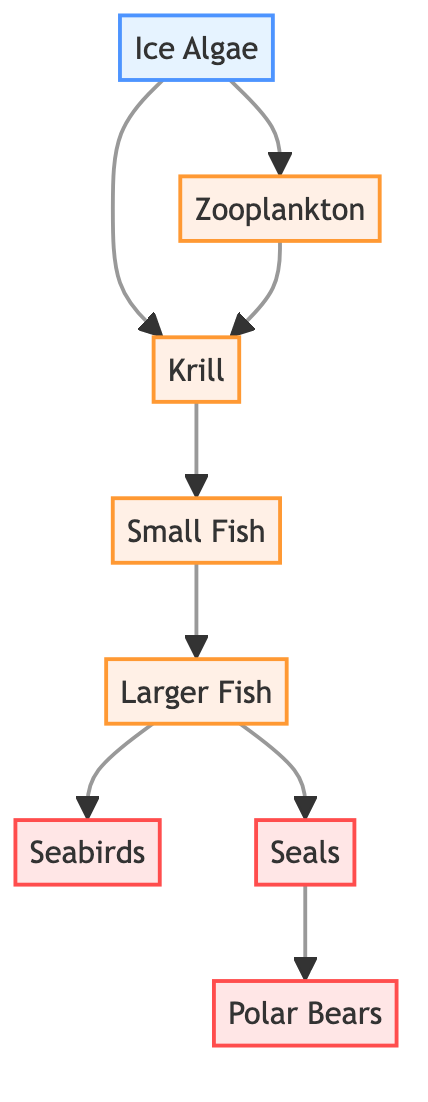What is the base of this food chain? The base of the food chain is depicted as the first node in the flowchart, which is Ice Algae.
Answer: Ice Algae How many consumers are present in the food chain? The consumers are the organisms that directly eat or receive energy from the primary producers. In the diagram, Zooplankton, Krill, Small Fish, Larger Fish, Seabirds, and Seals are all consumers, totaling six.
Answer: 6 Which organism directly feeds on Krill? In the diagram, the Small Fish, which is linked directly after Krill, are the ones that feed on Krill.
Answer: Small Fish Who is the apex predator in this food chain? The apex predator, occupying the highest position on the flowchart and not being eaten by any other organism in this network, is the Polar Bears.
Answer: Polar Bears What type of organisms are Seabirds considered in this food chain? In the structure of the food chain shown in the diagram, Seabirds are classified under the predator category, as they eat the Larger Fish.
Answer: Predator How many levels are there in this food chain from Ice Algae to Polar Bears? To determine the levels, we can count from Ice Algae at the base, moving through each tier until reaching Polar Bears. This results in a total of 7 levels.
Answer: 7 Which two organisms feed on Larger Fish? The diagram shows that Seabirds and Polar Bears both feed on Larger Fish, confirming their role as predators in the chain.
Answer: Seabirds and Polar Bears Is Krill a primary producer or a consumer in this ecosystem? Krill is not capable of photosynthesis and relies on other organisms for energy, placing it in the consumer category as shown in the diagram.
Answer: Consumer What links Ice Algae to the next level in the food chain? The connections extending from the Ice Algae in the chart demonstrate that both Zooplankton and Krill directly derive energy from it.
Answer: Zooplankton and Krill 